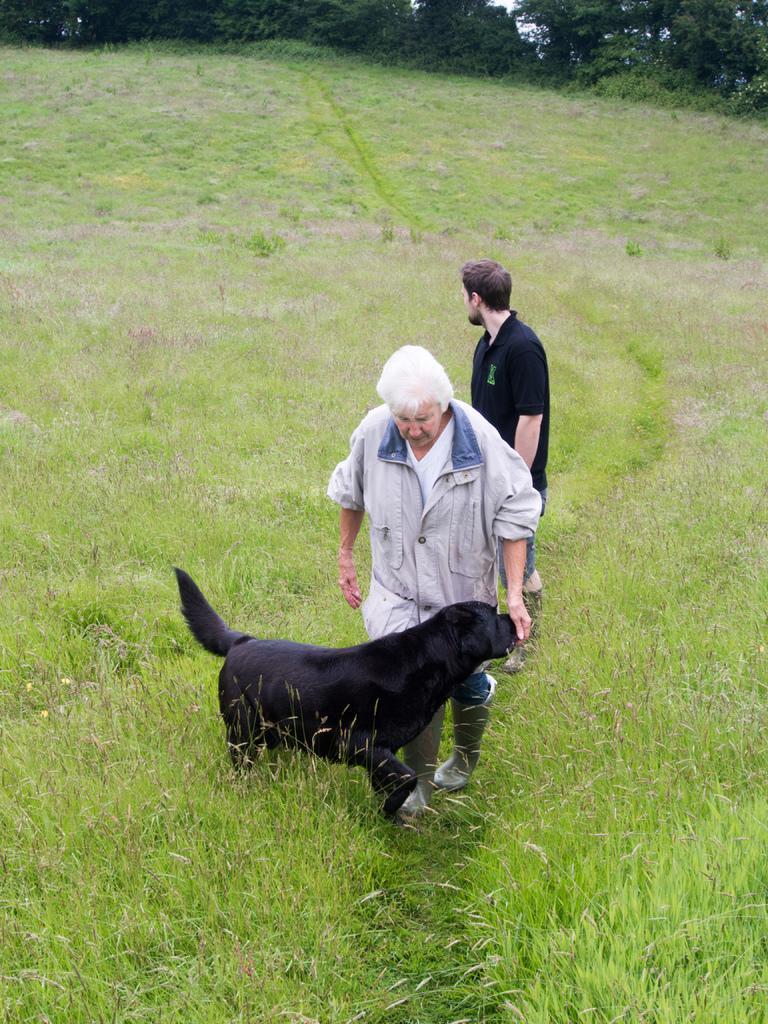How would you summarize this image in a sentence or two? In this image we can see two persons, among them, one person is holding a dog, there are some trees and grass on the ground, also we can see the sky. 